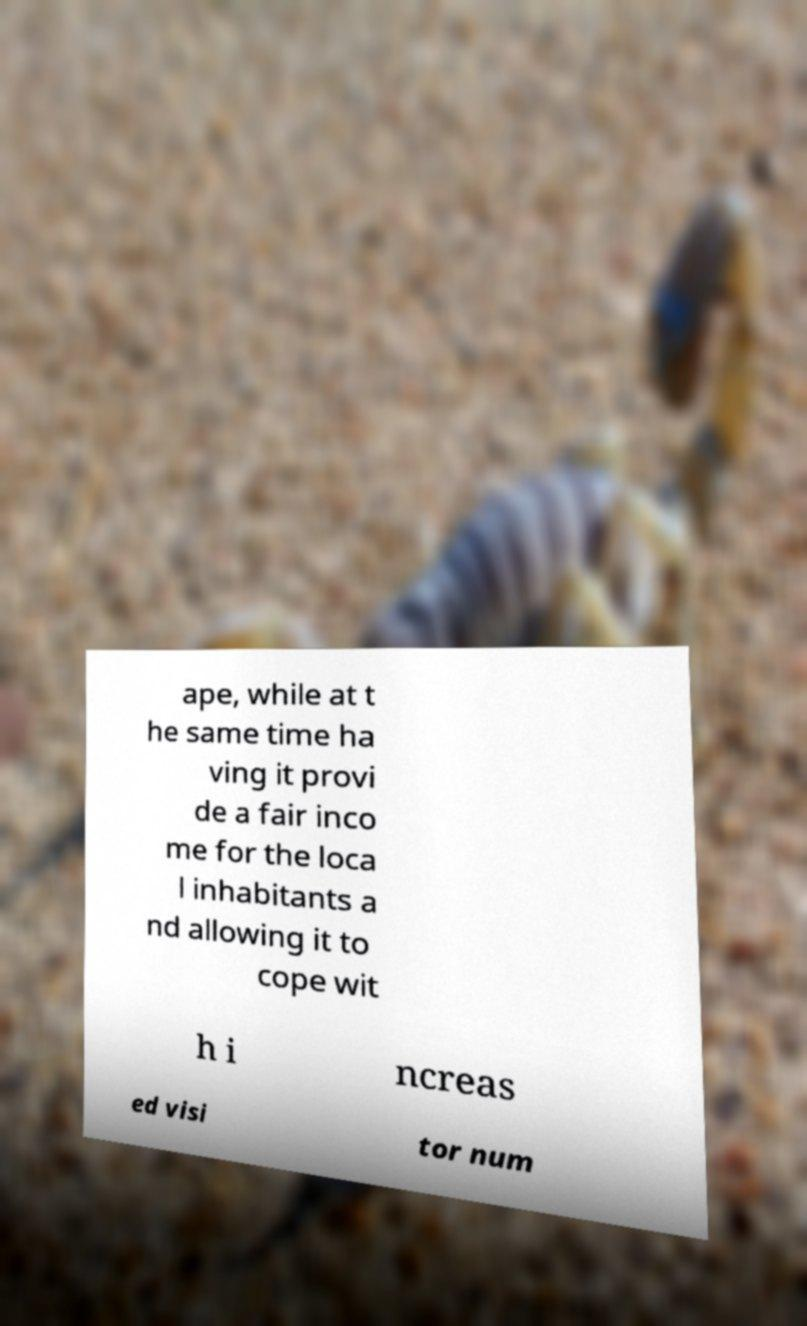Can you accurately transcribe the text from the provided image for me? ape, while at t he same time ha ving it provi de a fair inco me for the loca l inhabitants a nd allowing it to cope wit h i ncreas ed visi tor num 